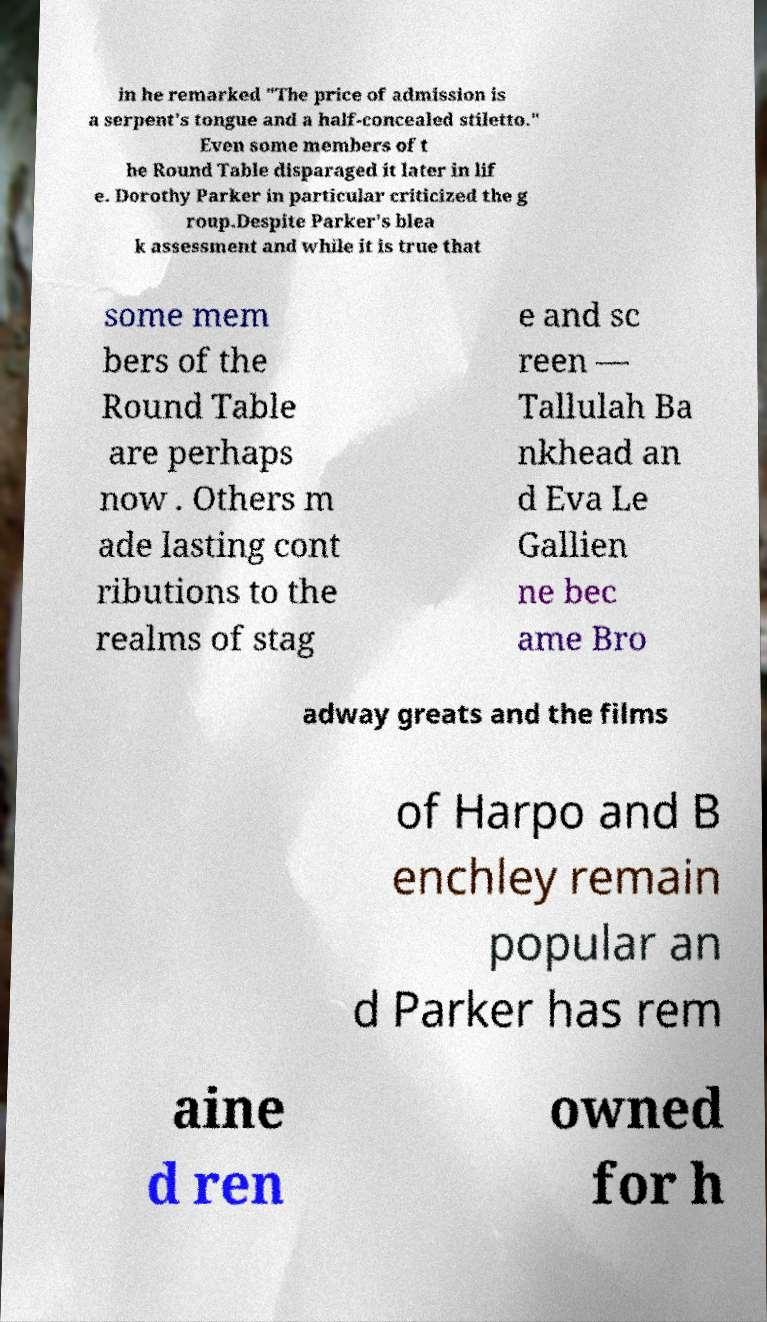What messages or text are displayed in this image? I need them in a readable, typed format. in he remarked "The price of admission is a serpent's tongue and a half-concealed stiletto." Even some members of t he Round Table disparaged it later in lif e. Dorothy Parker in particular criticized the g roup.Despite Parker's blea k assessment and while it is true that some mem bers of the Round Table are perhaps now . Others m ade lasting cont ributions to the realms of stag e and sc reen — Tallulah Ba nkhead an d Eva Le Gallien ne bec ame Bro adway greats and the films of Harpo and B enchley remain popular an d Parker has rem aine d ren owned for h 